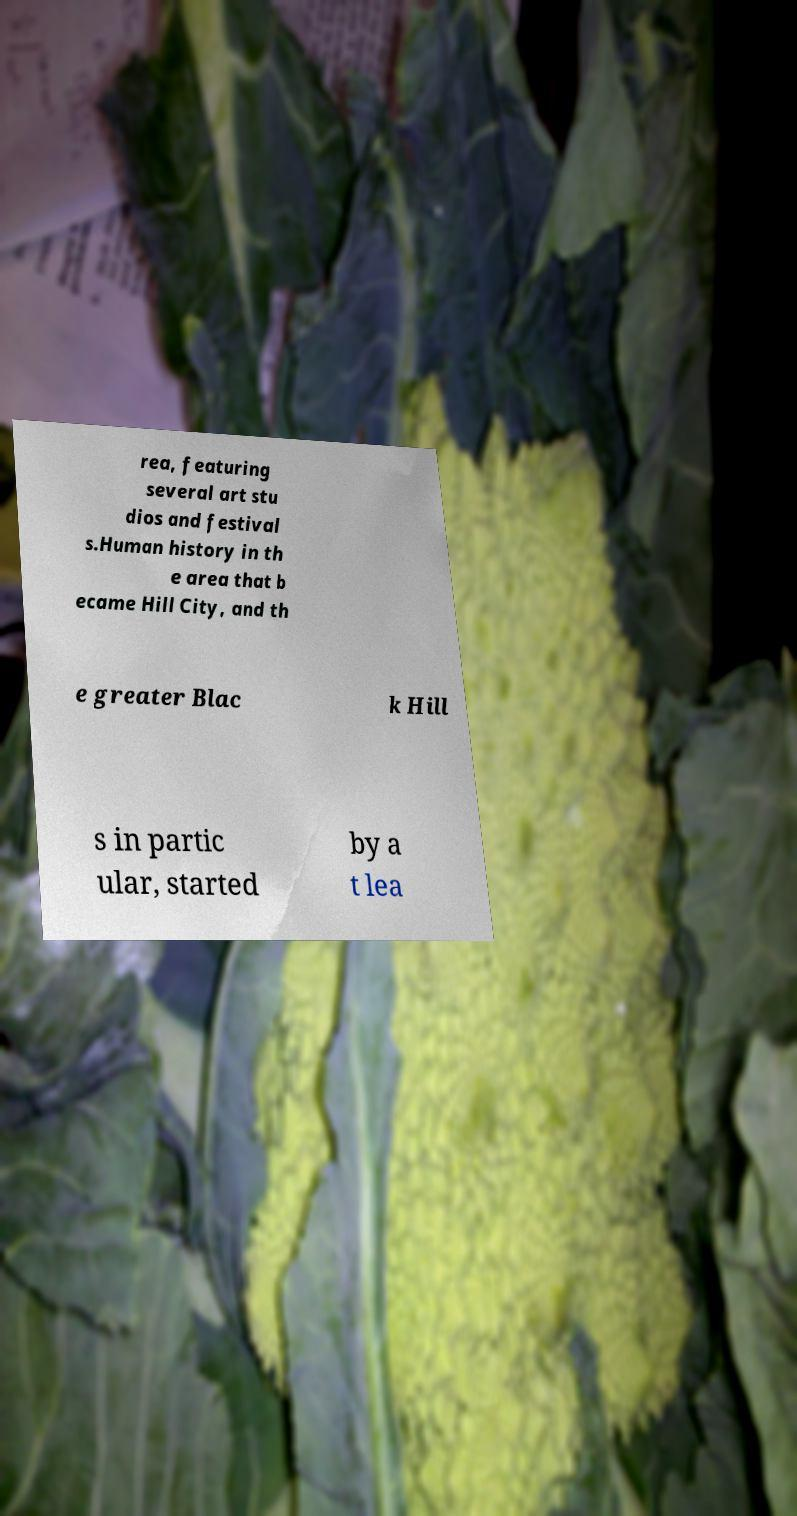I need the written content from this picture converted into text. Can you do that? rea, featuring several art stu dios and festival s.Human history in th e area that b ecame Hill City, and th e greater Blac k Hill s in partic ular, started by a t lea 